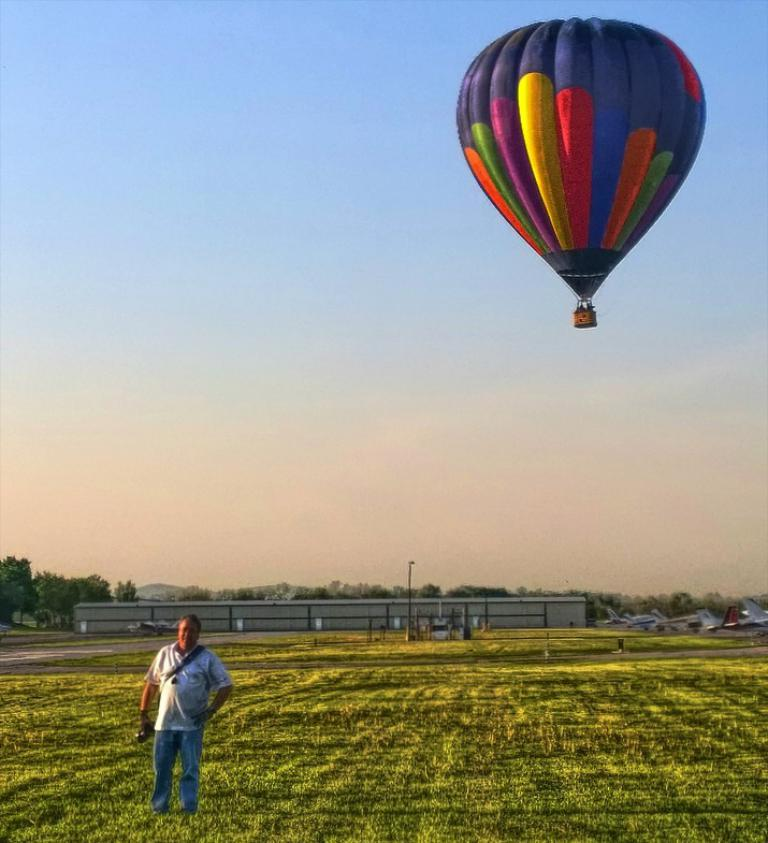What is the man in the image standing on? The man is standing on the grass. What can be seen in the background of the image? There is a building, a pole, trees, and airplanes in the background. What is visible in the sky? The sky is visible in the image. What is the man holding in the image? The man is holding a parachute. What type of jelly is being served at the event in the image? There is no event or jelly present in the image; it features a man standing on the grass with a parachute. How many pizzas are visible on the table in the image? There is no table or pizzas present in the image. 